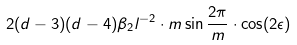Convert formula to latex. <formula><loc_0><loc_0><loc_500><loc_500>2 ( d - 3 ) ( d - 4 ) \beta _ { 2 } l ^ { - 2 } \cdot m \sin \frac { 2 \pi } { m } \cdot \cos ( 2 \epsilon )</formula> 